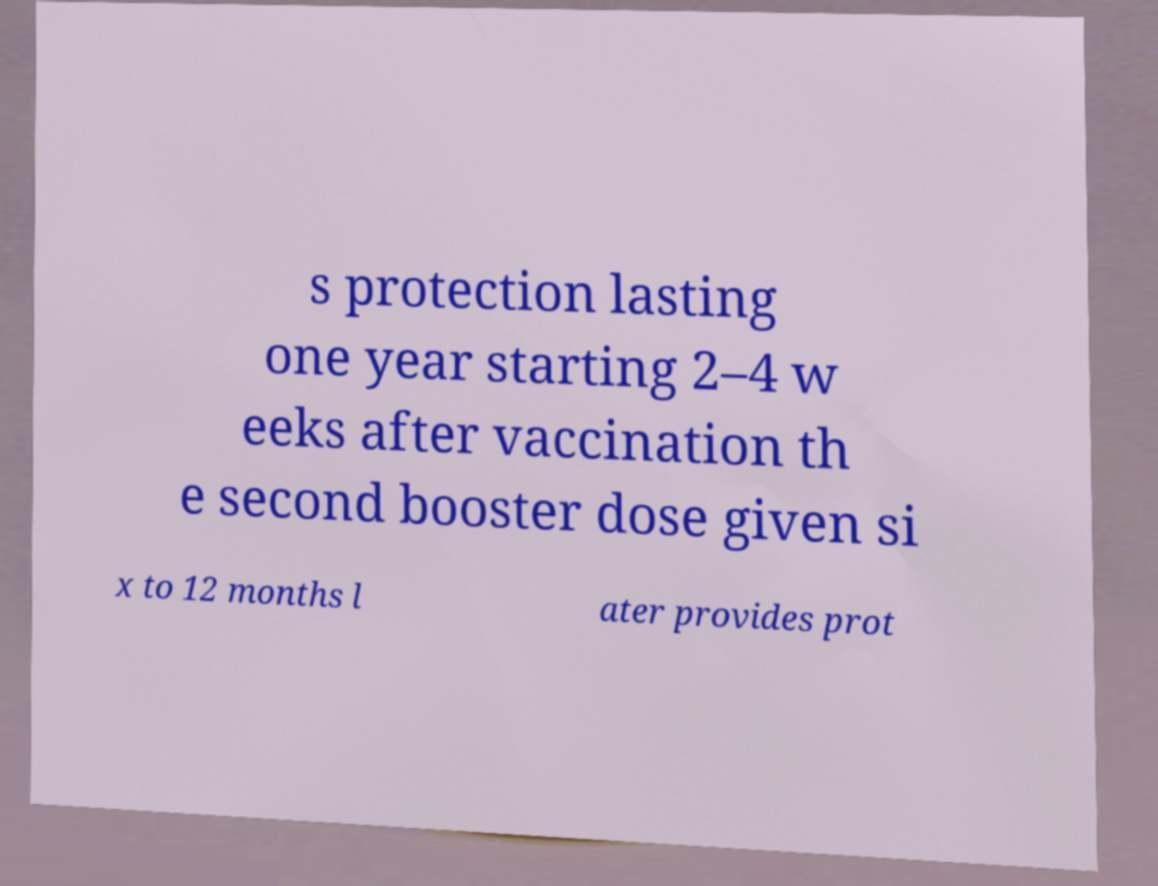Can you accurately transcribe the text from the provided image for me? s protection lasting one year starting 2–4 w eeks after vaccination th e second booster dose given si x to 12 months l ater provides prot 